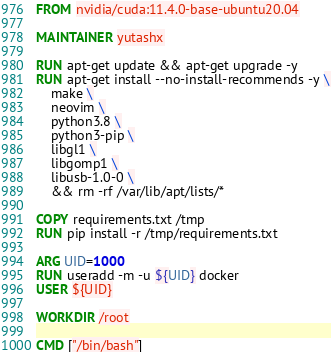Convert code to text. <code><loc_0><loc_0><loc_500><loc_500><_Dockerfile_>FROM nvidia/cuda:11.4.0-base-ubuntu20.04

MAINTAINER yutashx

RUN apt-get update && apt-get upgrade -y
RUN apt-get install --no-install-recommends -y \
    make \
    neovim \
    python3.8 \
    python3-pip \
    libgl1 \
    libgomp1 \
    libusb-1.0-0 \
    && rm -rf /var/lib/apt/lists/*

COPY requirements.txt /tmp
RUN pip install -r /tmp/requirements.txt

ARG UID=1000
RUN useradd -m -u ${UID} docker
USER ${UID}

WORKDIR /root

CMD ["/bin/bash"]
</code> 